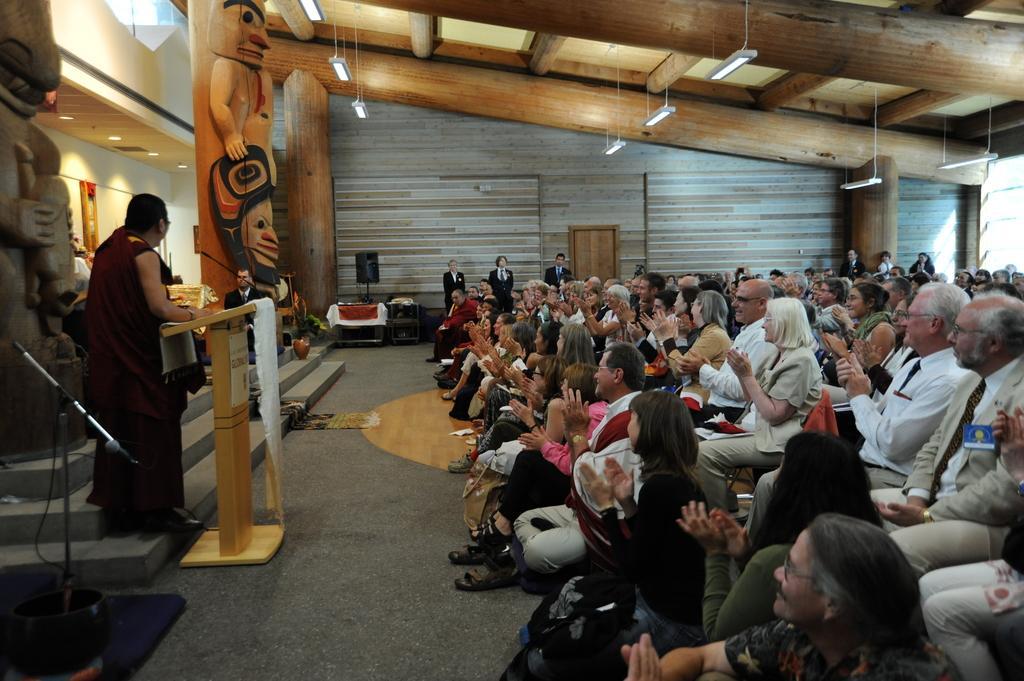Please provide a concise description of this image. On the left side, there is a person in brown color dress, standing on a step and placing hand on the stand, which is covered with white color cloth and is having a mic. In front of him, there are persons sitting on chairs and clapping. In the background, there are persons standing, near wall, there are pillars, there are lights arranged on the roof, there is a statue and there are other objects. 